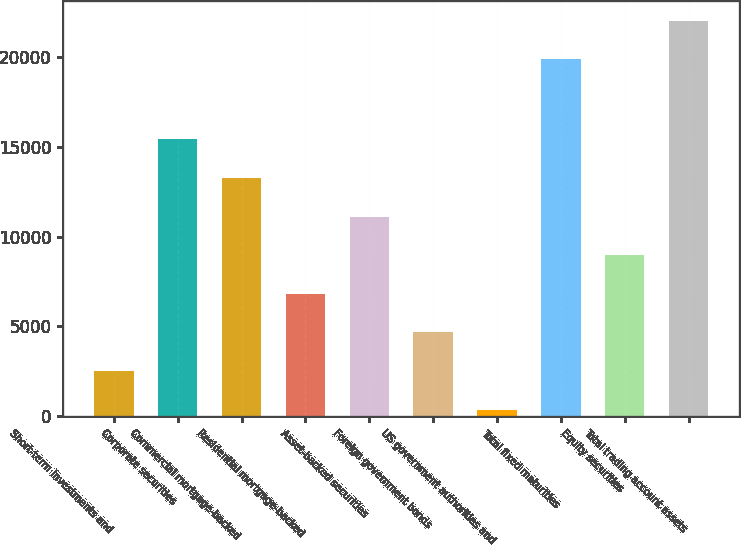Convert chart. <chart><loc_0><loc_0><loc_500><loc_500><bar_chart><fcel>Short-term investments and<fcel>Corporate securities<fcel>Commercial mortgage-backed<fcel>Residential mortgage-backed<fcel>Asset-backed securities<fcel>Foreign government bonds<fcel>US government authorities and<fcel>Total fixed maturities<fcel>Equity securities<fcel>Total trading account assets<nl><fcel>2522.4<fcel>15400.8<fcel>13254.4<fcel>6815.2<fcel>11108<fcel>4668.8<fcel>376<fcel>19850<fcel>8961.6<fcel>21996.4<nl></chart> 